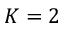<formula> <loc_0><loc_0><loc_500><loc_500>K = 2</formula> 